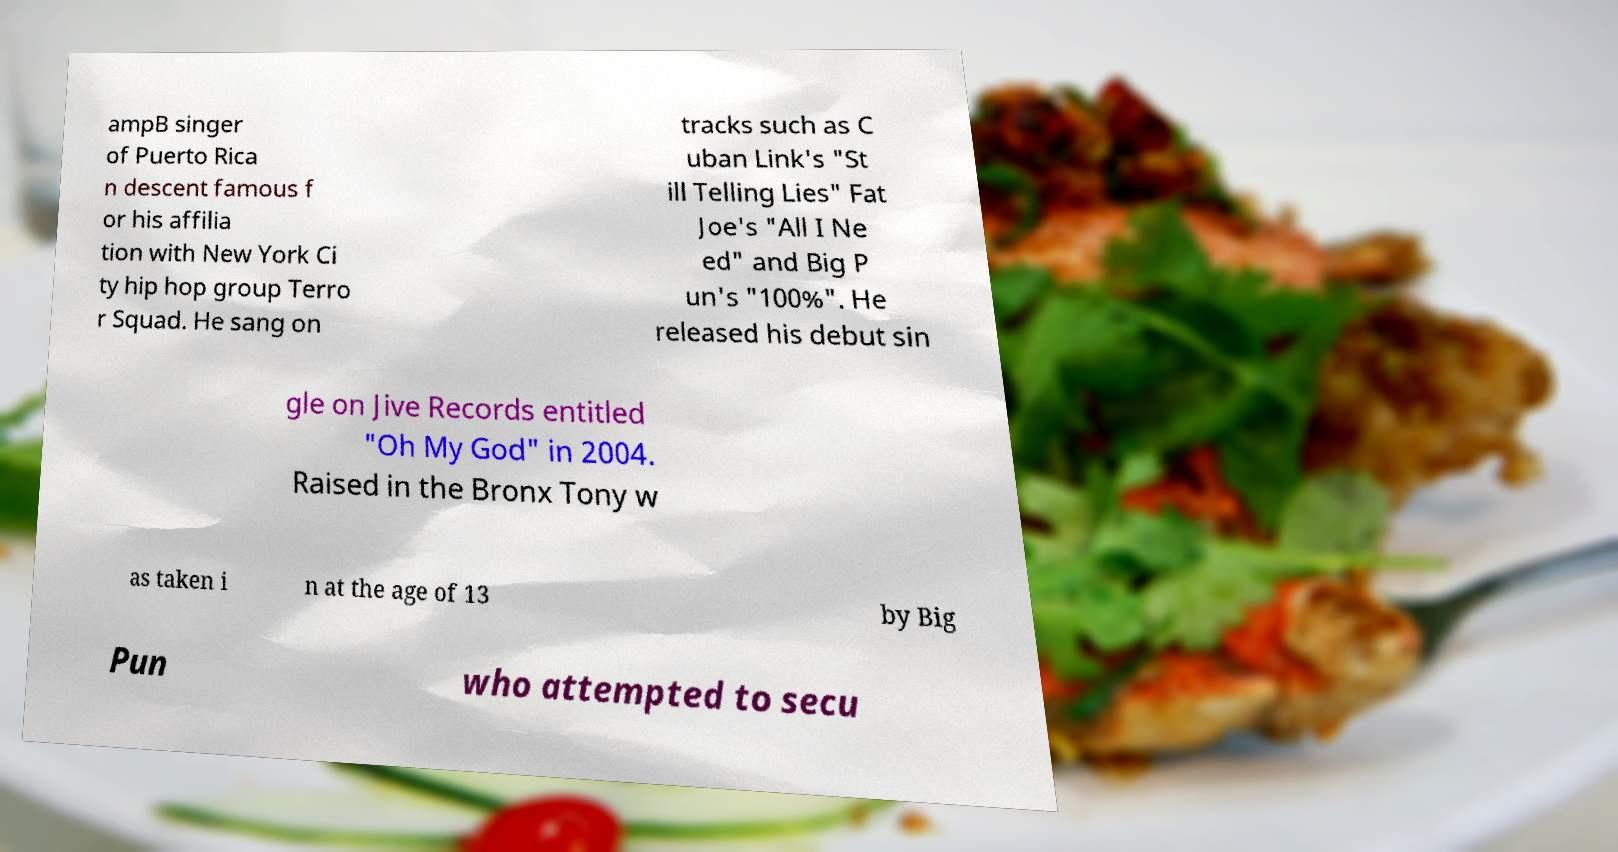Please identify and transcribe the text found in this image. ampB singer of Puerto Rica n descent famous f or his affilia tion with New York Ci ty hip hop group Terro r Squad. He sang on tracks such as C uban Link's "St ill Telling Lies" Fat Joe's "All I Ne ed" and Big P un's "100%". He released his debut sin gle on Jive Records entitled "Oh My God" in 2004. Raised in the Bronx Tony w as taken i n at the age of 13 by Big Pun who attempted to secu 